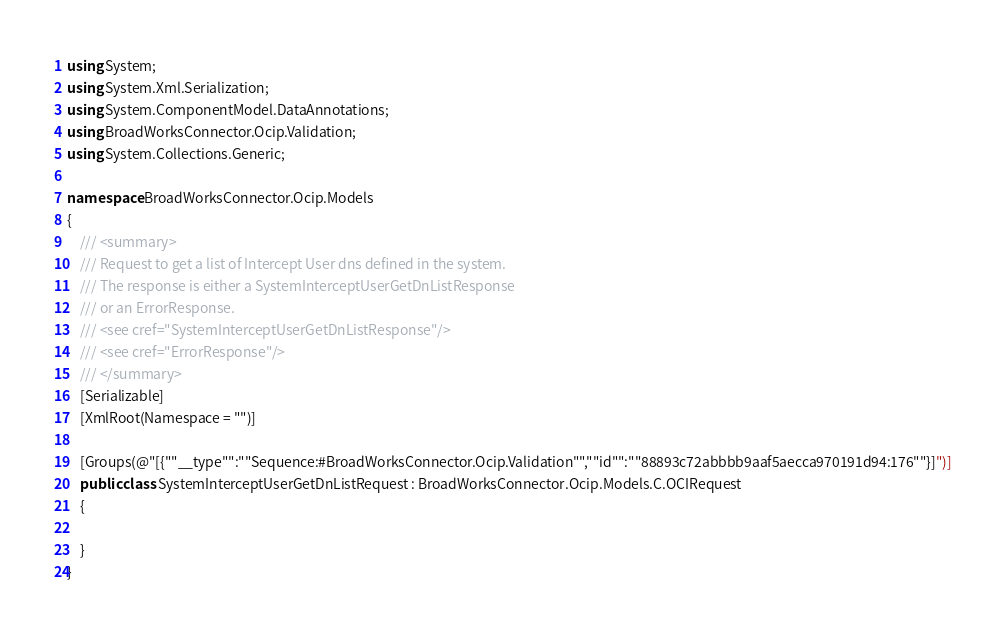<code> <loc_0><loc_0><loc_500><loc_500><_C#_>using System;
using System.Xml.Serialization;
using System.ComponentModel.DataAnnotations;
using BroadWorksConnector.Ocip.Validation;
using System.Collections.Generic;

namespace BroadWorksConnector.Ocip.Models
{
    /// <summary>
    /// Request to get a list of Intercept User dns defined in the system.
    /// The response is either a SystemInterceptUserGetDnListResponse
    /// or an ErrorResponse.
    /// <see cref="SystemInterceptUserGetDnListResponse"/>
    /// <see cref="ErrorResponse"/>
    /// </summary>
    [Serializable]
    [XmlRoot(Namespace = "")]

    [Groups(@"[{""__type"":""Sequence:#BroadWorksConnector.Ocip.Validation"",""id"":""88893c72abbbb9aaf5aecca970191d94:176""}]")]
    public class SystemInterceptUserGetDnListRequest : BroadWorksConnector.Ocip.Models.C.OCIRequest
    {

    }
}
</code> 